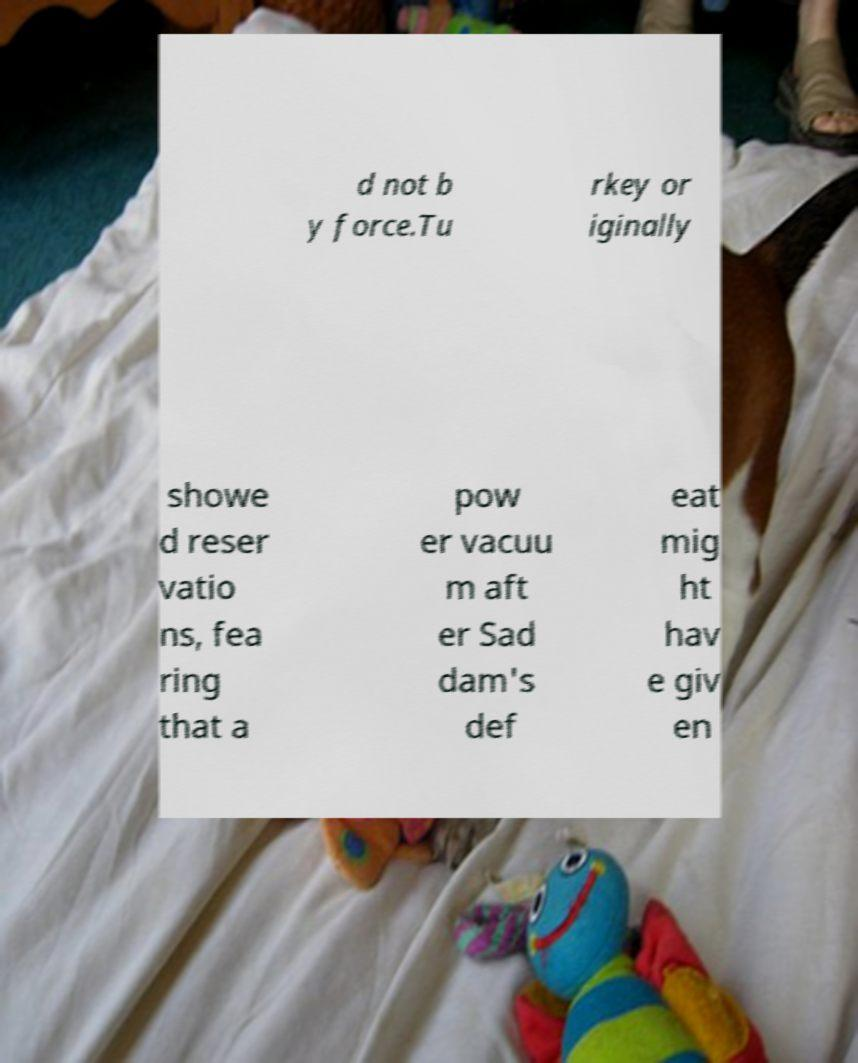Please read and relay the text visible in this image. What does it say? d not b y force.Tu rkey or iginally showe d reser vatio ns, fea ring that a pow er vacuu m aft er Sad dam's def eat mig ht hav e giv en 